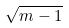<formula> <loc_0><loc_0><loc_500><loc_500>\sqrt { m - 1 }</formula> 